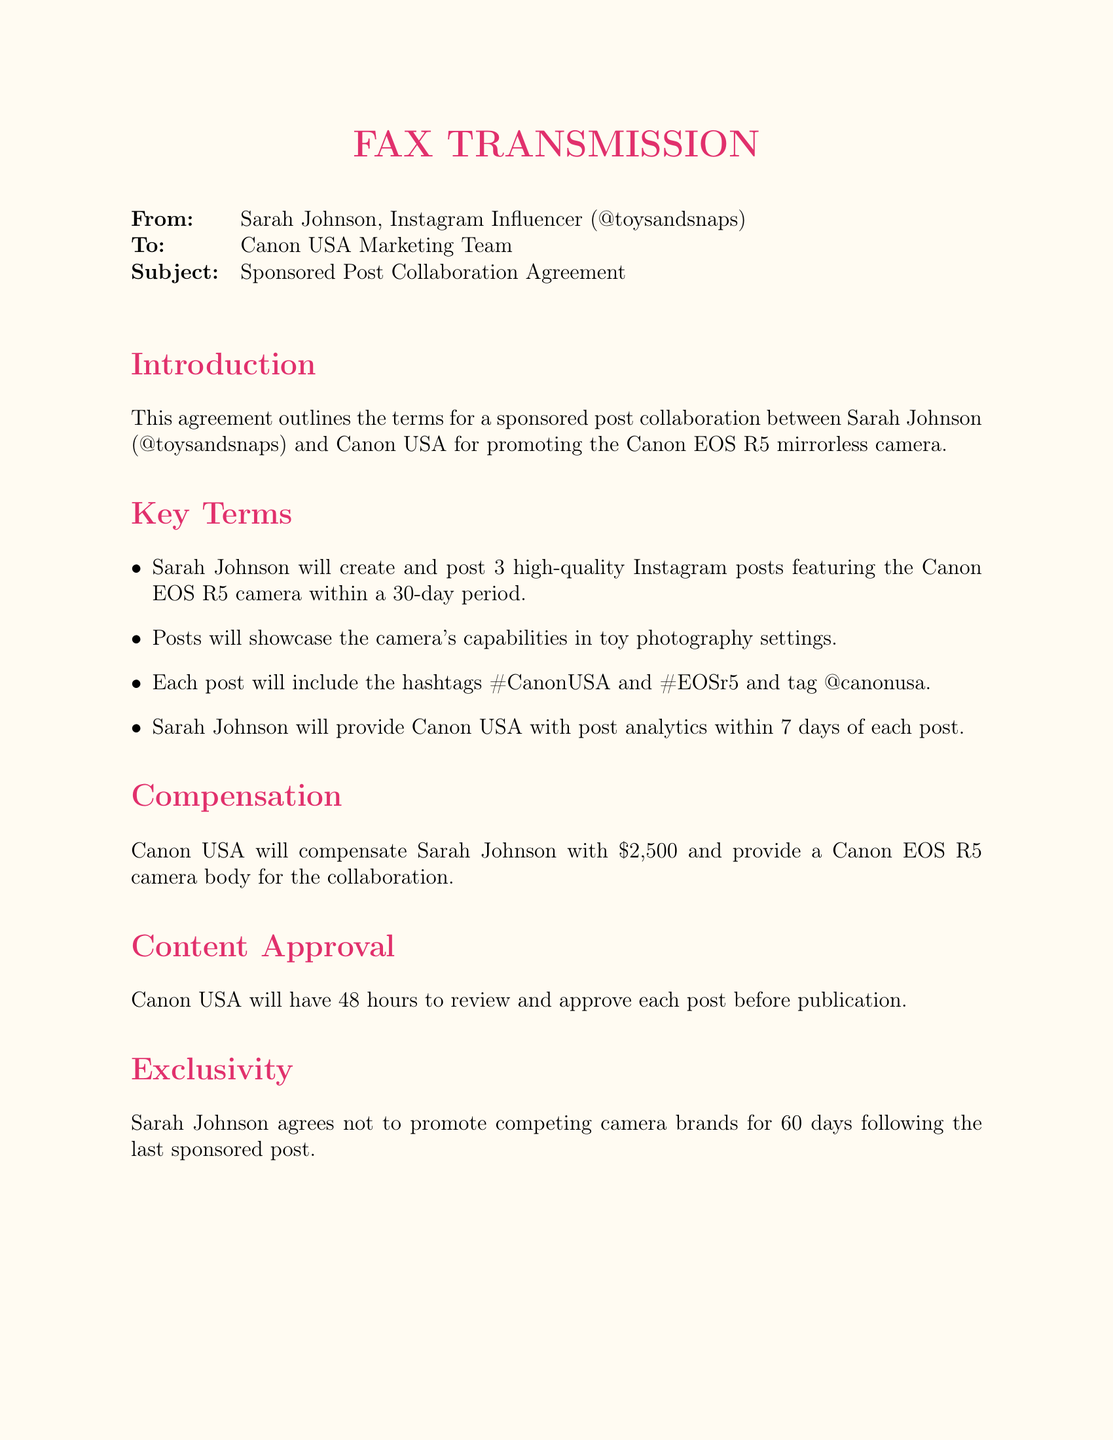What is the influencer's Instagram handle? The influencer's handle is given at the beginning of the document under "From:" as @toysandsnaps.
Answer: @toysandsnaps What camera model is being promoted? The document mentions the Canon EOS R5 camera in the introduction and key terms.
Answer: Canon EOS R5 How many posts will Sarah Johnson create? The key terms outline that Sarah Johnson will create 3 Instagram posts.
Answer: 3 What is the total compensation amount? The compensation section states that Canon USA will pay Sarah Johnson $2,500.
Answer: $2,500 How long does Canon USA have to approve each post? The document specifies that Canon USA has 48 hours for post approval.
Answer: 48 hours What is the exclusivity period after the last sponsored post? The exclusivity section states an agreement not to promote competing brands for 60 days.
Answer: 60 days Who is the brand representative? The document identifies John Smith as the Canon USA Marketing Manager.
Answer: John Smith What must Sarah Johnson provide Canon USA after each post? The key terms mention that Sarah Johnson will provide post analytics within 7 days of each post.
Answer: Post analytics How much notice is required for termination? The termination section states that either party may terminate with 14 days written notice.
Answer: 14 days 